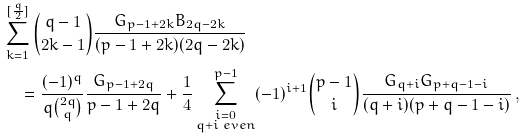<formula> <loc_0><loc_0><loc_500><loc_500>& \sum _ { k = 1 } ^ { [ \frac { q } { 2 } ] } \binom { q - 1 } { 2 k - 1 } \frac { G _ { p - 1 + 2 k } B _ { 2 q - 2 k } } { ( p - 1 + 2 k ) ( 2 q - 2 k ) } \\ & \quad = \frac { ( - 1 ) ^ { q } } { q \binom { 2 q } { q } } \frac { G _ { p - 1 + 2 q } } { p - 1 + 2 q } + \frac { 1 } { 4 } \sum _ { \substack { i = 0 \\ q + i \ e v e n } } ^ { p - 1 } ( - 1 ) ^ { i + 1 } \binom { p - 1 } { i } \frac { G _ { q + i } G _ { p + q - 1 - i } } { ( q + i ) ( p + q - 1 - i ) } \, ,</formula> 